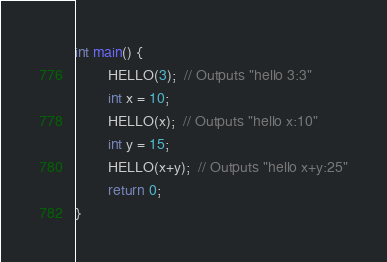Convert code to text. <code><loc_0><loc_0><loc_500><loc_500><_C_>int main() {
        HELLO(3);  // Outputs "hello 3:3"
        int x = 10;
        HELLO(x);  // Outputs "hello x:10"
        int y = 15;
        HELLO(x+y);  // Outputs "hello x+y:25"
        return 0;
}
</code> 